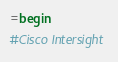Convert code to text. <code><loc_0><loc_0><loc_500><loc_500><_Ruby_>=begin
#Cisco Intersight
</code> 